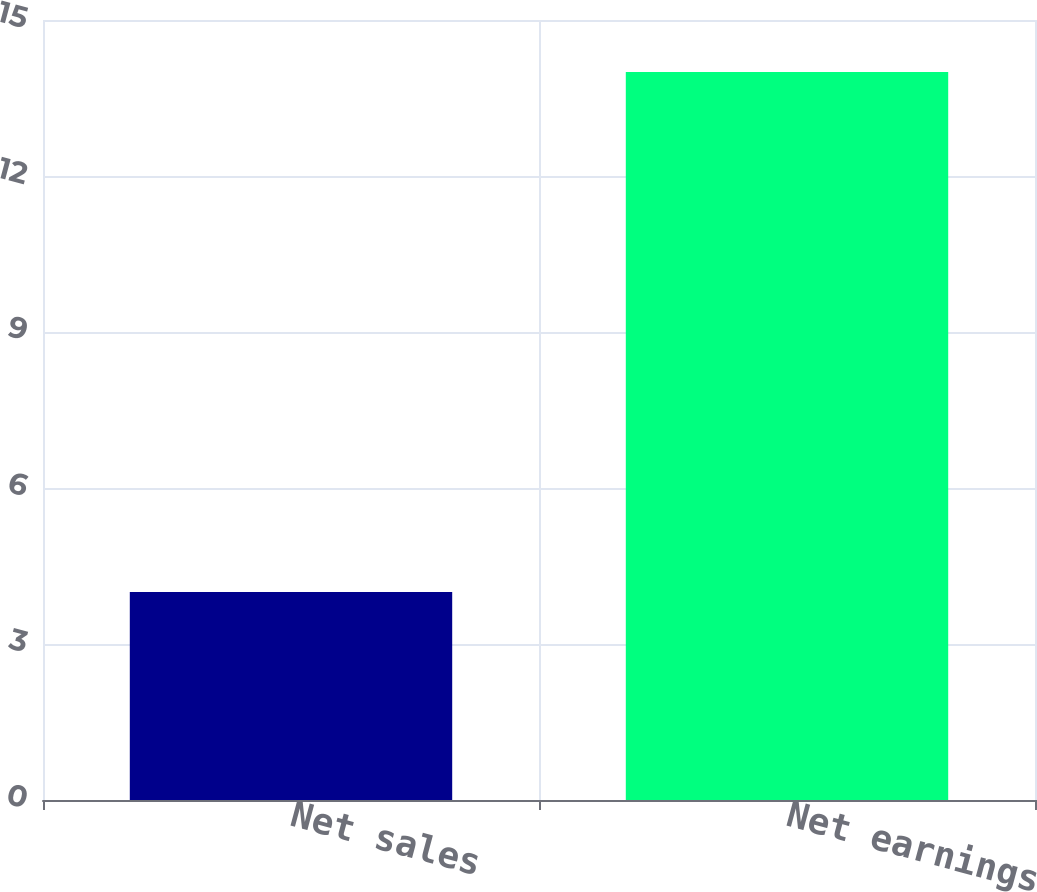Convert chart. <chart><loc_0><loc_0><loc_500><loc_500><bar_chart><fcel>Net sales<fcel>Net earnings<nl><fcel>4<fcel>14<nl></chart> 